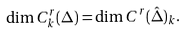Convert formula to latex. <formula><loc_0><loc_0><loc_500><loc_500>\dim C _ { k } ^ { r } ( \Delta ) = \dim C ^ { r } ( \hat { \Delta } ) _ { k } .</formula> 